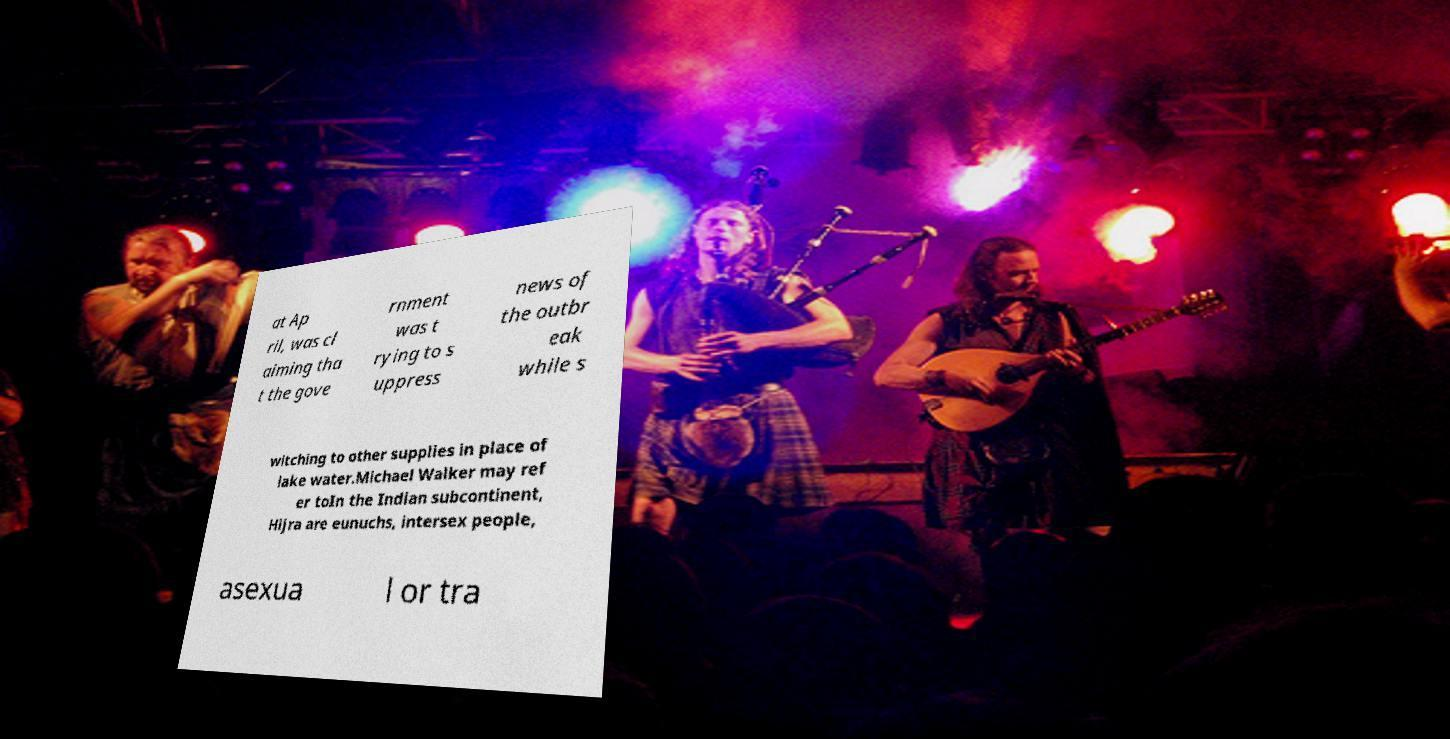What messages or text are displayed in this image? I need them in a readable, typed format. at Ap ril, was cl aiming tha t the gove rnment was t rying to s uppress news of the outbr eak while s witching to other supplies in place of lake water.Michael Walker may ref er toIn the Indian subcontinent, Hijra are eunuchs, intersex people, asexua l or tra 